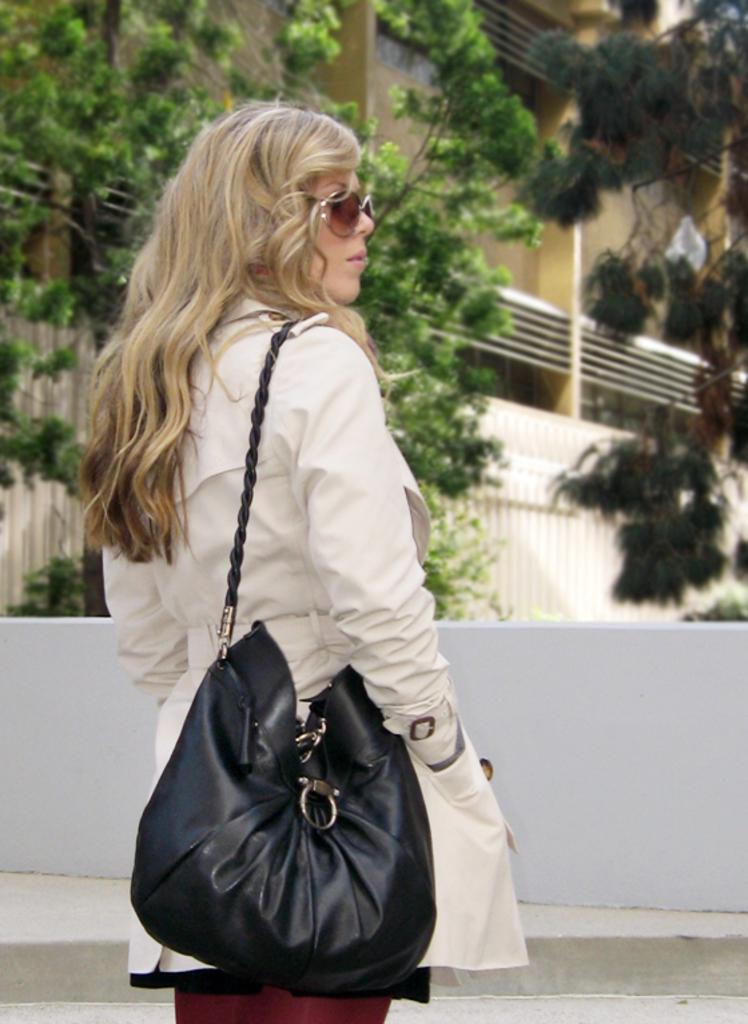In one or two sentences, can you explain what this image depicts? In this picture we can see women wore goggles carrying bag and standing on a floor and in the background we can see wall, trees, building, wires. 